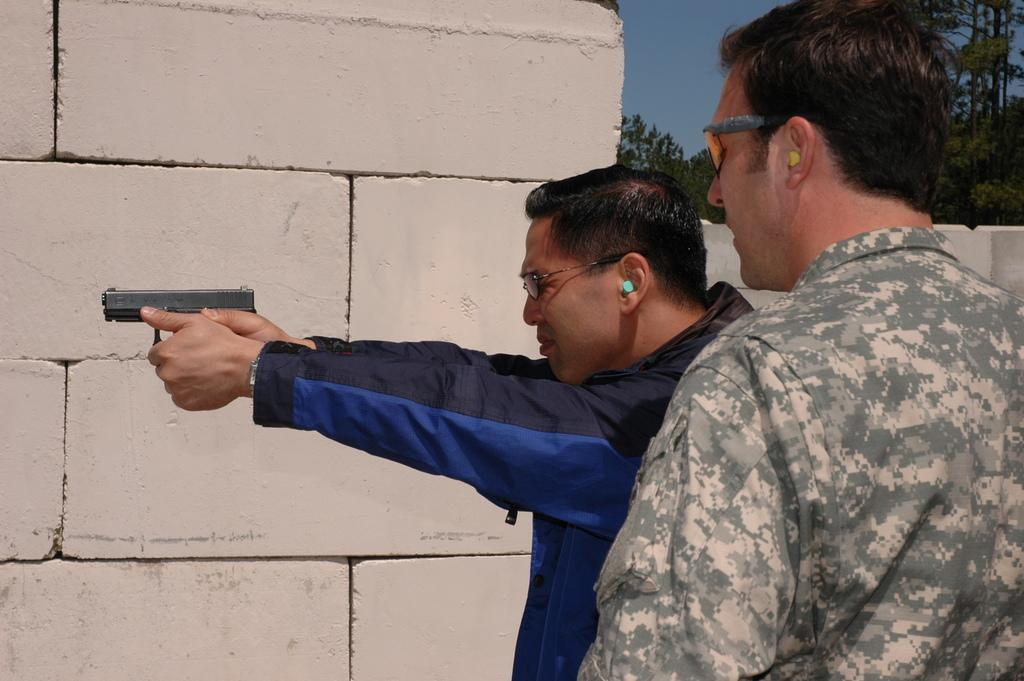How many people are in the image? There are two persons in the image. What is located behind the persons? There is a wall behind the persons. What can be seen in the background of the image? There are trees and the sky visible in the background of the image. Where is the desk located in the image? There is no desk present in the image. How many children are visible in the image? There is no mention of children in the image; it features two persons. 